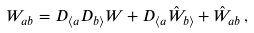<formula> <loc_0><loc_0><loc_500><loc_500>W _ { a b } = D _ { \langle a } D _ { b \rangle } W + D _ { \langle a } \hat { W } _ { b \rangle } + \hat { W } _ { a b } \, ,</formula> 